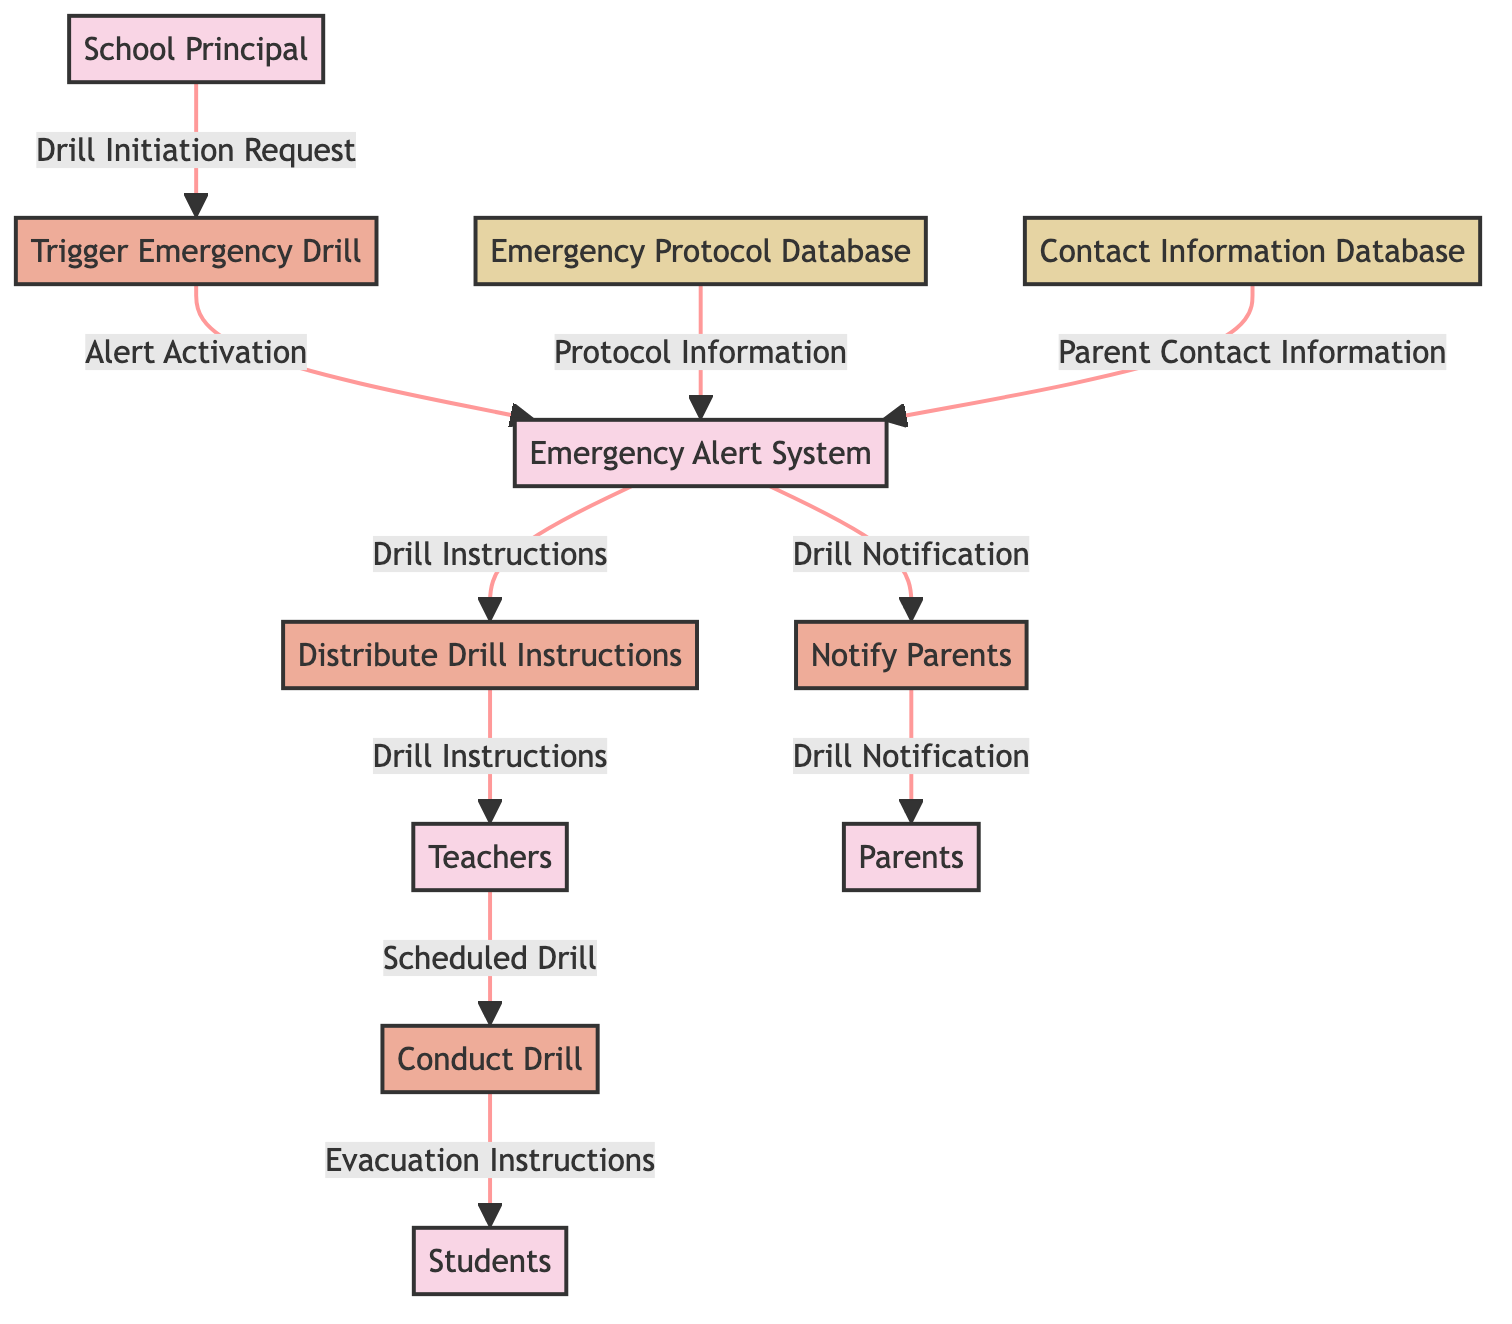What is the first process initiated by the School Principal? The first process listed in the diagram that is initiated by the School Principal is "Trigger Emergency Drill." This is identified as it directly follows the School Principal in the flow of the diagram.
Answer: Trigger Emergency Drill How many external entities are present in the diagram? The diagram includes five external entities: School Principal, Emergency Alert System, Teachers, Students, and Parents. By counting each distinct entity, the total comes to five.
Answer: Five What data is sent from the Teachers to the Conduct Drill process? The Teachers send "Scheduled Drill" data to the Conduct Drill process. This specific flow is indicated directly between the Teachers and Conduct Drill in the diagram.
Answer: Scheduled Drill Which process is responsible for notifying the Parents? The process responsible for notifying the Parents is "Notify Parents." This can be traced from the Emergency Alert System, which feeds into this process in the diagram layout.
Answer: Notify Parents What data flows from the Emergency Protocol Database to the Emergency Alert System? The data that flows from the Emergency Protocol Database to the Emergency Alert System is "Protocol Information." This association is clearly outlined in the data flow lines that connect these two nodes.
Answer: Protocol Information How does the Emergency Alert System receive Parent Contact Information? The Emergency Alert System receives "Parent Contact Information" from the Contact Information Database. The flow from the database to the system is explicitly drawn in the diagram.
Answer: Parent Contact Information What is the final output of the Conduct Drill process? The final output produced by the Conduct Drill process is "Evacuation Instructions," which is directed towards the Students, as indicated in the data flow from Conduct Drill to Students.
Answer: Evacuation Instructions Which external entity receives the Drill Notification? The Drill Notification is received by the Parents. This is a direct outcome of the Notify Parents process, which sends the notification to the external entity representing Parents in the diagram.
Answer: Parents What initiates the distribution of Drill Instructions? The distribution of Drill Instructions is initiated by the Emergency Alert System, which receives its inputs from the Trigger Emergency Drill process. This sequence is depicted in the flow between those two processes.
Answer: Emergency Alert System How many processes are in the diagram? There are four processes identified in the diagram: Trigger Emergency Drill, Distribute Drill Instructions, Conduct Drill, and Notify Parents. These processes are clearly listed, and a simple count confirms the total.
Answer: Four 